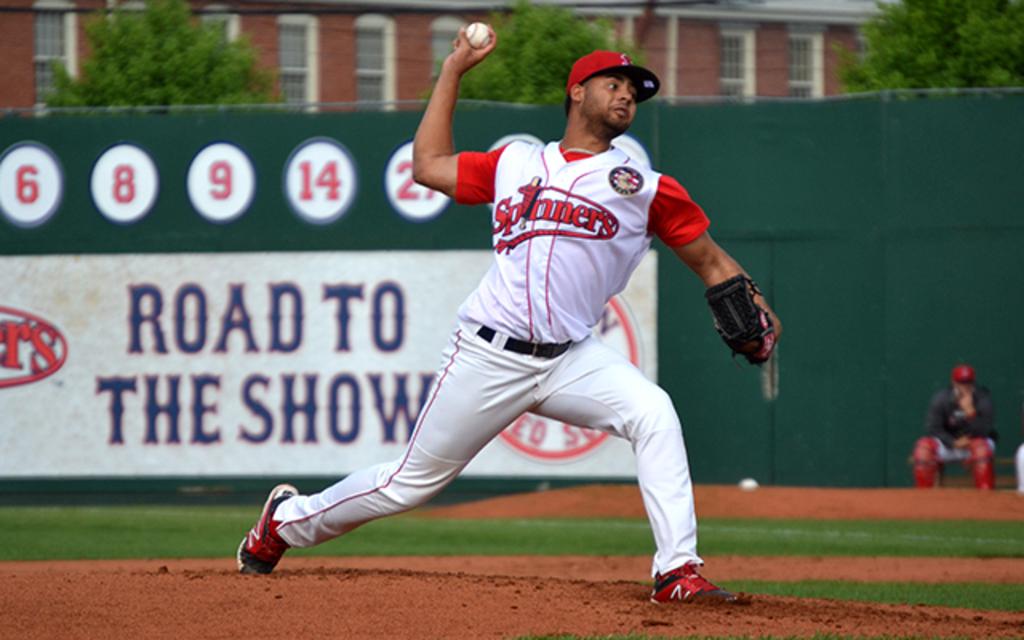The five numbers in red read?
Your answer should be very brief. 6 8 9 14 27. 